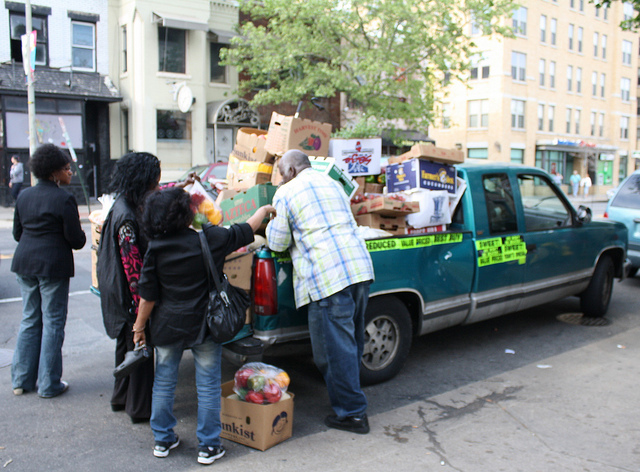<image>What is the company's slogan? I don't know the company's slogan. It is hard to tell and cannot read. What is the company's slogan? I don't know the company's slogan. It is hard to tell from the image. 